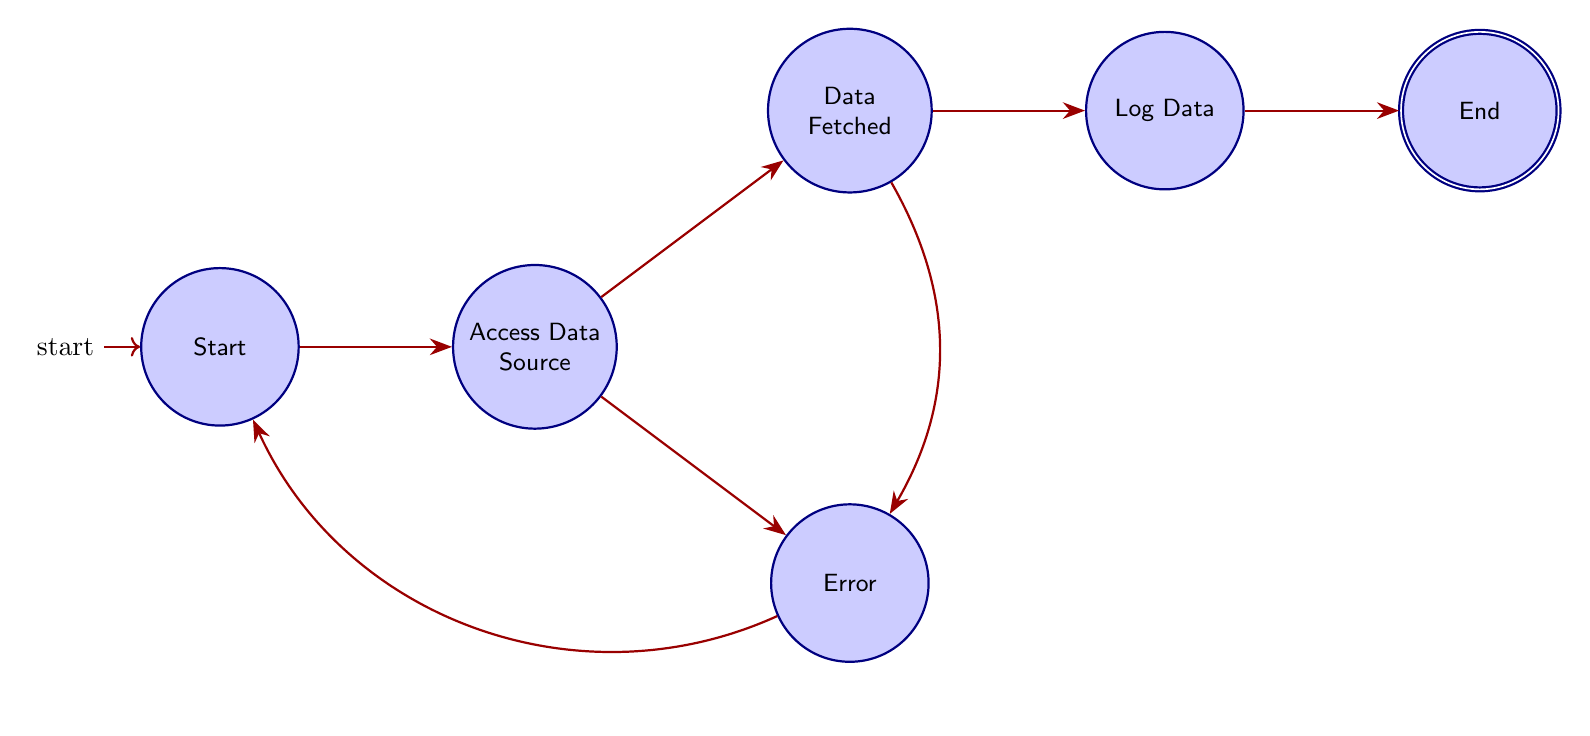What is the initial state of this Finite State Machine? The initial state is commonly represented in diagrams with a distinct marking or indicator, and here it is labeled as "Start."
Answer: Start How many states are present in the diagram? To find the number of states, we can count each circle or labeled node in the diagram. There are six states: Start, Access Data Source, Data Fetched, Error, Log Data, and End.
Answer: 6 Which state comes after "Access Data Source" if data is successfully fetched? According to the transition rules shown in the diagram, the successful fetching of data leads directly to the "Data Fetched" state from "Access Data Source."
Answer: Data Fetched What happens if there is an error during data fetching? If an error occurs in fetching data, the diagram indicates a transition from the "Access Data Source" state to the "Error" state.
Answer: Error After logging the data, which state is reached next? Once the "Log Data" state is completed, the next logical step is to transition to the "End" state, marking the completion of the process.
Answer: End From the "Error" state, where does the machine transition? The diagram states that from the "Error" state, the next transition returns to the "Start" state, allowing for another attempt to access the data source.
Answer: Start Which node is directly linked to "Log Data"? The only node that transitions directly to "Log Data" is "Data Fetched," as indicated in the diagram's structure and flow.
Answer: Data Fetched What is the last state of the process? The last state in the diagram is labeled as "End," which signifies that all operations have been successfully completed.
Answer: End 